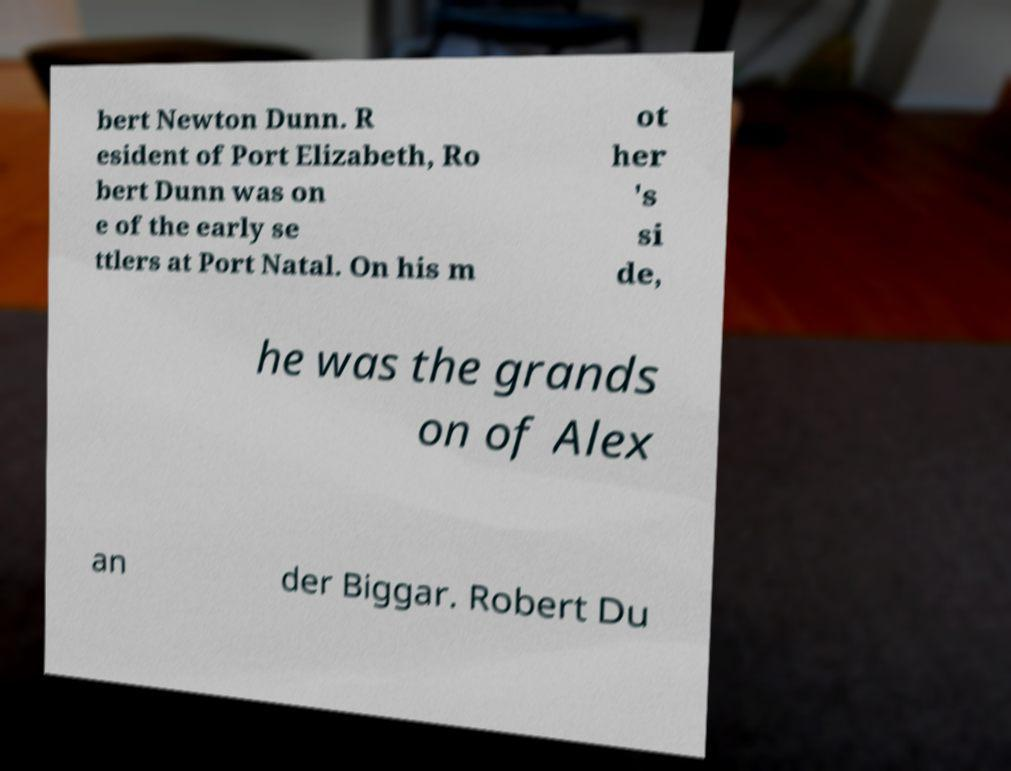There's text embedded in this image that I need extracted. Can you transcribe it verbatim? bert Newton Dunn. R esident of Port Elizabeth, Ro bert Dunn was on e of the early se ttlers at Port Natal. On his m ot her 's si de, he was the grands on of Alex an der Biggar. Robert Du 